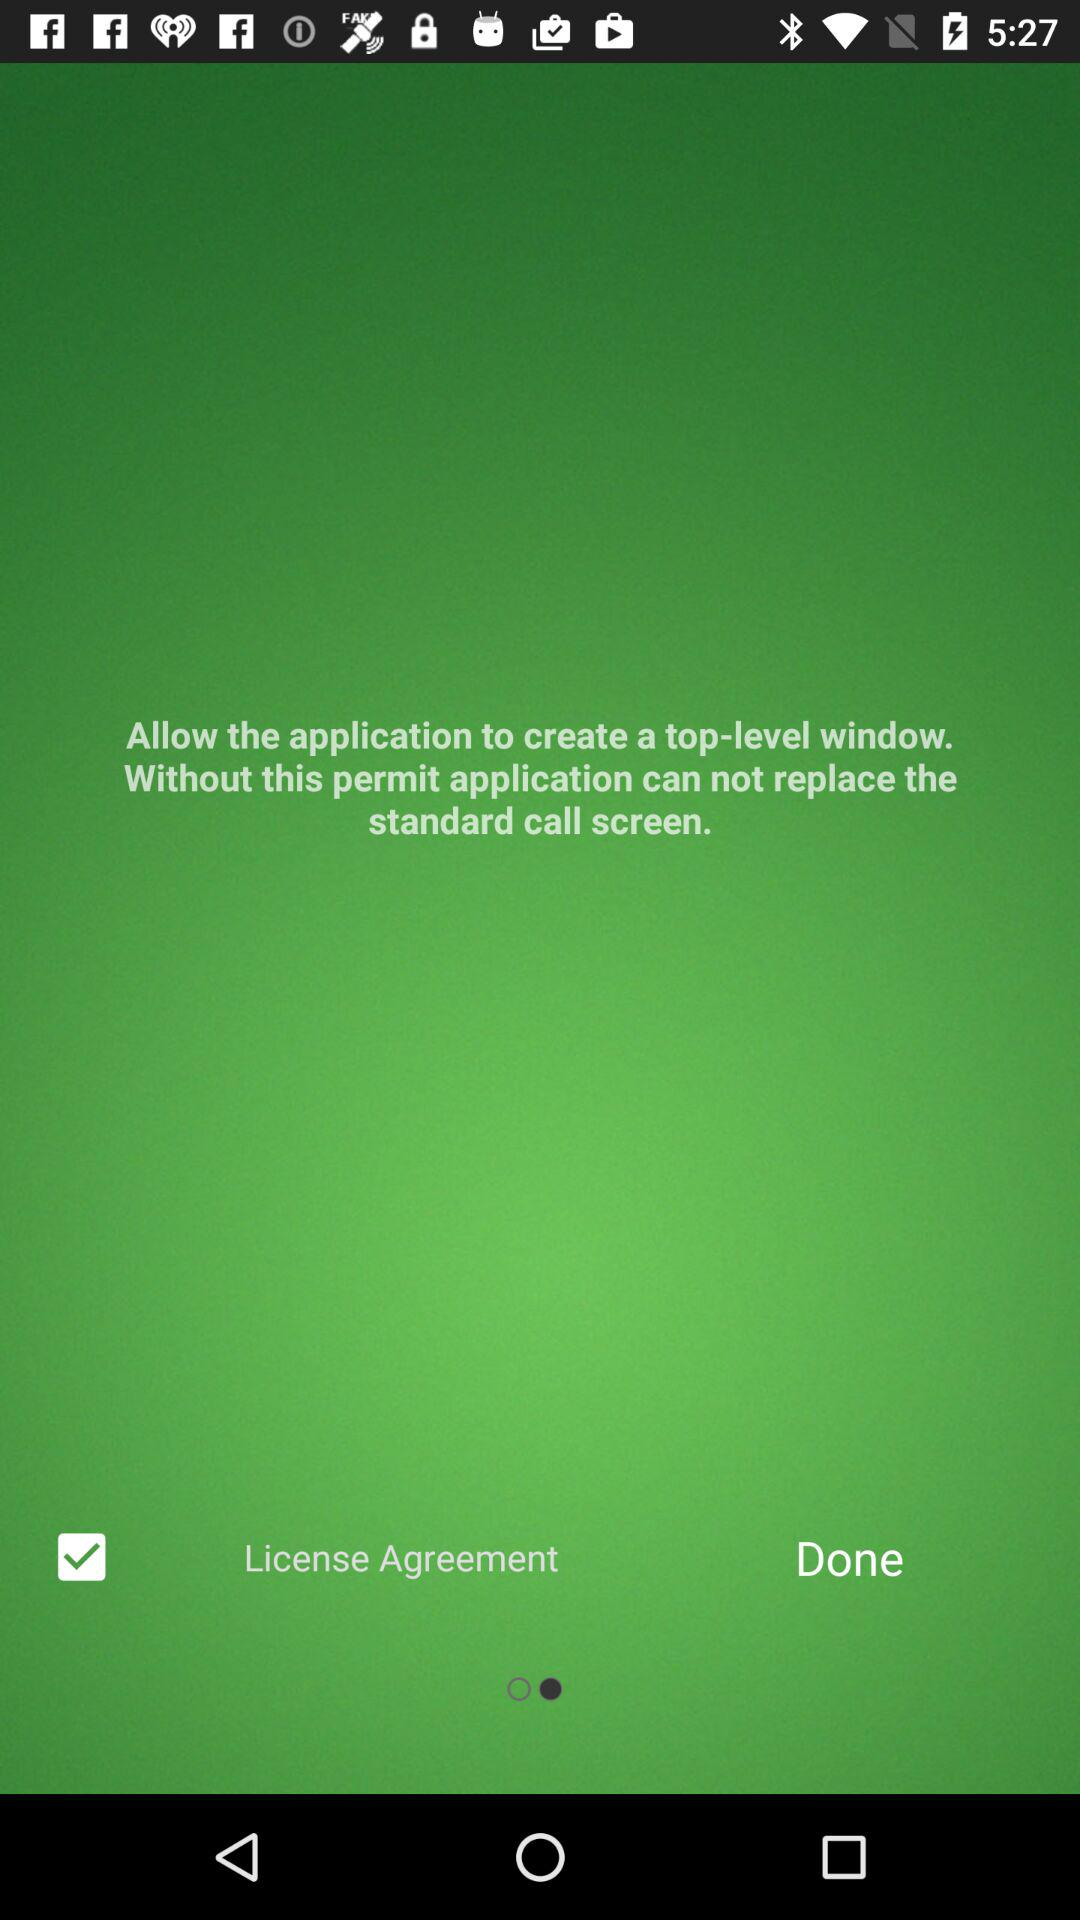What is the status of "License Agreement"? The status of "License Agreement" is "on". 